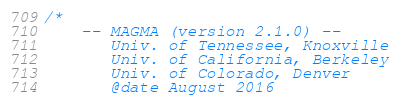<code> <loc_0><loc_0><loc_500><loc_500><_Cuda_>/*
    -- MAGMA (version 2.1.0) --
       Univ. of Tennessee, Knoxville
       Univ. of California, Berkeley
       Univ. of Colorado, Denver
       @date August 2016
</code> 